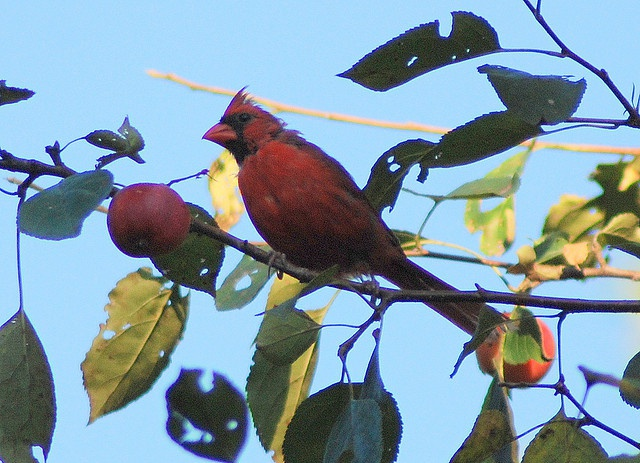Describe the objects in this image and their specific colors. I can see bird in lightblue, black, maroon, brown, and gray tones, apple in lightblue, maroon, black, purple, and brown tones, and apple in lightblue, maroon, salmon, gray, and tan tones in this image. 